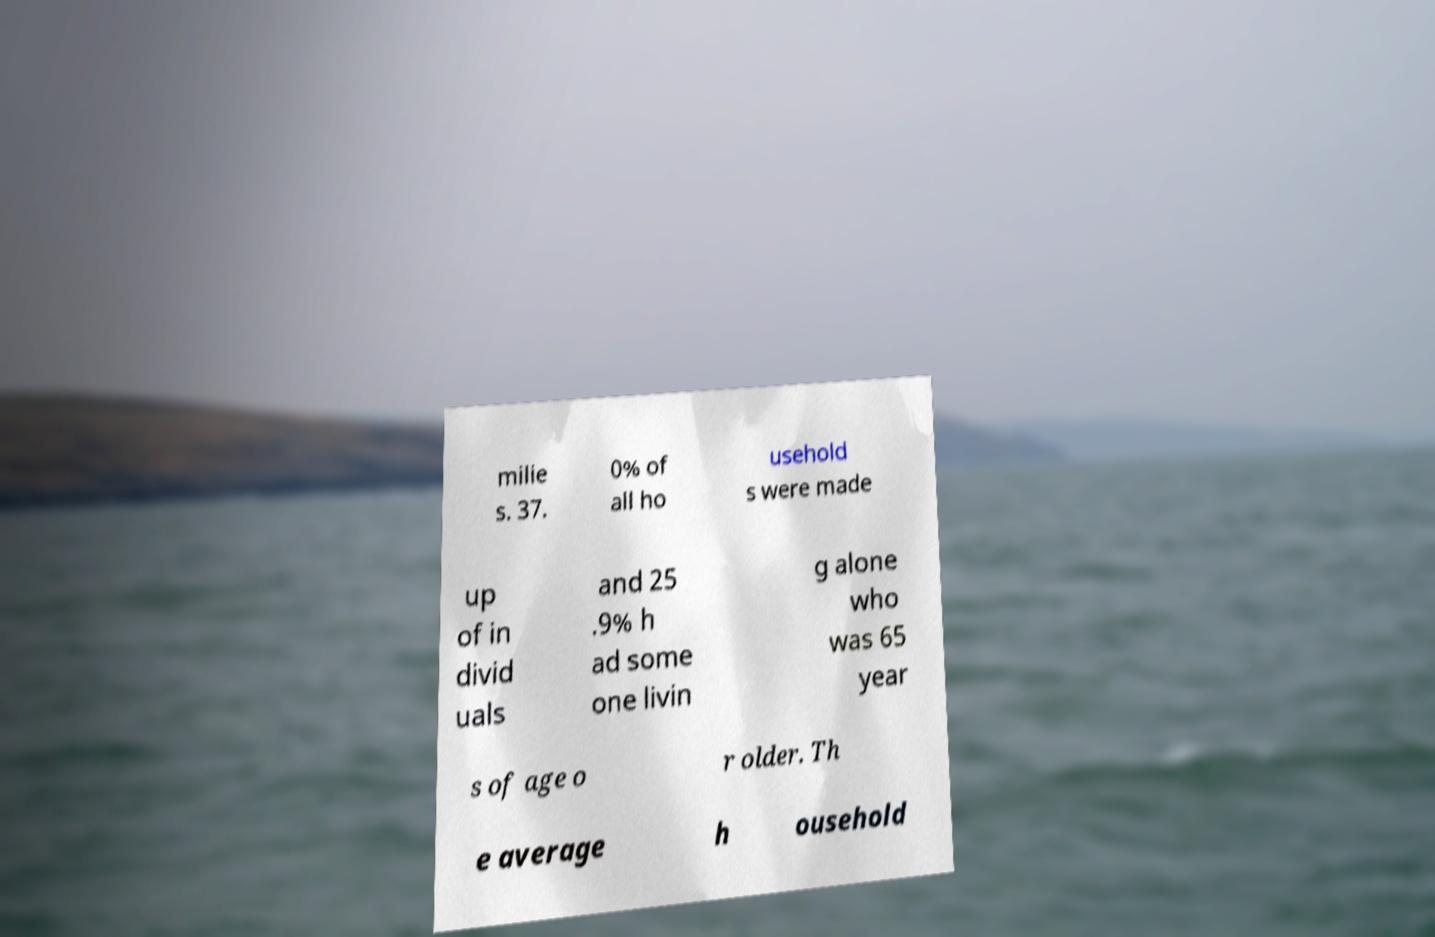I need the written content from this picture converted into text. Can you do that? milie s. 37. 0% of all ho usehold s were made up of in divid uals and 25 .9% h ad some one livin g alone who was 65 year s of age o r older. Th e average h ousehold 